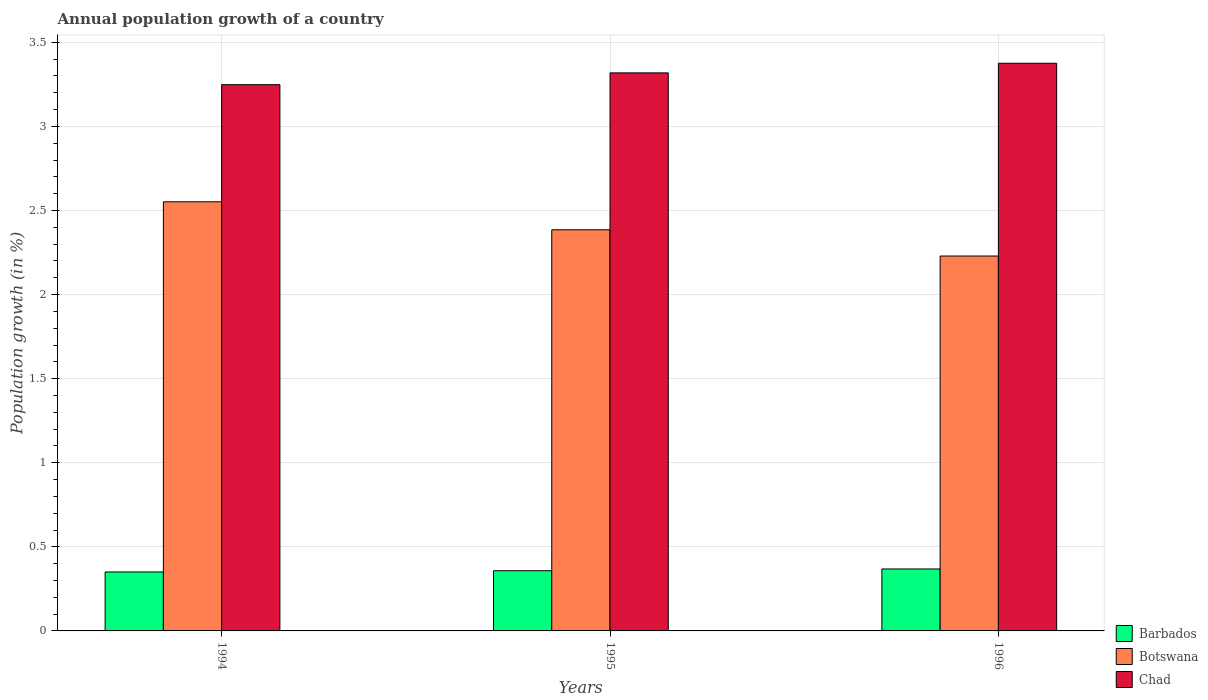Are the number of bars per tick equal to the number of legend labels?
Give a very brief answer. Yes. Are the number of bars on each tick of the X-axis equal?
Make the answer very short. Yes. How many bars are there on the 3rd tick from the right?
Make the answer very short. 3. What is the label of the 1st group of bars from the left?
Ensure brevity in your answer.  1994. What is the annual population growth in Barbados in 1995?
Give a very brief answer. 0.36. Across all years, what is the maximum annual population growth in Botswana?
Your response must be concise. 2.55. Across all years, what is the minimum annual population growth in Chad?
Offer a terse response. 3.25. In which year was the annual population growth in Barbados minimum?
Your answer should be compact. 1994. What is the total annual population growth in Barbados in the graph?
Ensure brevity in your answer.  1.08. What is the difference between the annual population growth in Chad in 1994 and that in 1995?
Your answer should be very brief. -0.07. What is the difference between the annual population growth in Barbados in 1996 and the annual population growth in Chad in 1994?
Ensure brevity in your answer.  -2.88. What is the average annual population growth in Barbados per year?
Offer a terse response. 0.36. In the year 1994, what is the difference between the annual population growth in Barbados and annual population growth in Botswana?
Make the answer very short. -2.2. What is the ratio of the annual population growth in Barbados in 1994 to that in 1996?
Ensure brevity in your answer.  0.95. What is the difference between the highest and the second highest annual population growth in Botswana?
Offer a very short reply. 0.17. What is the difference between the highest and the lowest annual population growth in Barbados?
Your answer should be compact. 0.02. What does the 3rd bar from the left in 1996 represents?
Provide a short and direct response. Chad. What does the 2nd bar from the right in 1994 represents?
Offer a very short reply. Botswana. How many years are there in the graph?
Your response must be concise. 3. What is the difference between two consecutive major ticks on the Y-axis?
Ensure brevity in your answer.  0.5. Does the graph contain any zero values?
Your response must be concise. No. Does the graph contain grids?
Make the answer very short. Yes. Where does the legend appear in the graph?
Make the answer very short. Bottom right. How are the legend labels stacked?
Offer a very short reply. Vertical. What is the title of the graph?
Your response must be concise. Annual population growth of a country. Does "Central African Republic" appear as one of the legend labels in the graph?
Give a very brief answer. No. What is the label or title of the Y-axis?
Make the answer very short. Population growth (in %). What is the Population growth (in %) of Barbados in 1994?
Offer a terse response. 0.35. What is the Population growth (in %) of Botswana in 1994?
Your response must be concise. 2.55. What is the Population growth (in %) of Chad in 1994?
Your answer should be very brief. 3.25. What is the Population growth (in %) in Barbados in 1995?
Make the answer very short. 0.36. What is the Population growth (in %) of Botswana in 1995?
Give a very brief answer. 2.39. What is the Population growth (in %) in Chad in 1995?
Your answer should be very brief. 3.32. What is the Population growth (in %) in Barbados in 1996?
Ensure brevity in your answer.  0.37. What is the Population growth (in %) in Botswana in 1996?
Provide a short and direct response. 2.23. What is the Population growth (in %) in Chad in 1996?
Ensure brevity in your answer.  3.38. Across all years, what is the maximum Population growth (in %) in Barbados?
Offer a terse response. 0.37. Across all years, what is the maximum Population growth (in %) of Botswana?
Provide a succinct answer. 2.55. Across all years, what is the maximum Population growth (in %) of Chad?
Make the answer very short. 3.38. Across all years, what is the minimum Population growth (in %) in Barbados?
Keep it short and to the point. 0.35. Across all years, what is the minimum Population growth (in %) of Botswana?
Make the answer very short. 2.23. Across all years, what is the minimum Population growth (in %) of Chad?
Keep it short and to the point. 3.25. What is the total Population growth (in %) in Barbados in the graph?
Your answer should be compact. 1.08. What is the total Population growth (in %) in Botswana in the graph?
Ensure brevity in your answer.  7.17. What is the total Population growth (in %) in Chad in the graph?
Offer a very short reply. 9.94. What is the difference between the Population growth (in %) of Barbados in 1994 and that in 1995?
Offer a very short reply. -0.01. What is the difference between the Population growth (in %) in Botswana in 1994 and that in 1995?
Your response must be concise. 0.17. What is the difference between the Population growth (in %) in Chad in 1994 and that in 1995?
Keep it short and to the point. -0.07. What is the difference between the Population growth (in %) of Barbados in 1994 and that in 1996?
Keep it short and to the point. -0.02. What is the difference between the Population growth (in %) of Botswana in 1994 and that in 1996?
Offer a very short reply. 0.32. What is the difference between the Population growth (in %) in Chad in 1994 and that in 1996?
Ensure brevity in your answer.  -0.13. What is the difference between the Population growth (in %) of Barbados in 1995 and that in 1996?
Give a very brief answer. -0.01. What is the difference between the Population growth (in %) in Botswana in 1995 and that in 1996?
Give a very brief answer. 0.16. What is the difference between the Population growth (in %) of Chad in 1995 and that in 1996?
Your response must be concise. -0.06. What is the difference between the Population growth (in %) in Barbados in 1994 and the Population growth (in %) in Botswana in 1995?
Provide a short and direct response. -2.03. What is the difference between the Population growth (in %) in Barbados in 1994 and the Population growth (in %) in Chad in 1995?
Provide a succinct answer. -2.97. What is the difference between the Population growth (in %) of Botswana in 1994 and the Population growth (in %) of Chad in 1995?
Make the answer very short. -0.77. What is the difference between the Population growth (in %) of Barbados in 1994 and the Population growth (in %) of Botswana in 1996?
Your response must be concise. -1.88. What is the difference between the Population growth (in %) in Barbados in 1994 and the Population growth (in %) in Chad in 1996?
Provide a succinct answer. -3.02. What is the difference between the Population growth (in %) in Botswana in 1994 and the Population growth (in %) in Chad in 1996?
Your answer should be compact. -0.82. What is the difference between the Population growth (in %) of Barbados in 1995 and the Population growth (in %) of Botswana in 1996?
Provide a succinct answer. -1.87. What is the difference between the Population growth (in %) of Barbados in 1995 and the Population growth (in %) of Chad in 1996?
Provide a short and direct response. -3.02. What is the difference between the Population growth (in %) in Botswana in 1995 and the Population growth (in %) in Chad in 1996?
Provide a succinct answer. -0.99. What is the average Population growth (in %) in Barbados per year?
Keep it short and to the point. 0.36. What is the average Population growth (in %) of Botswana per year?
Ensure brevity in your answer.  2.39. What is the average Population growth (in %) of Chad per year?
Your answer should be very brief. 3.31. In the year 1994, what is the difference between the Population growth (in %) of Barbados and Population growth (in %) of Botswana?
Offer a terse response. -2.2. In the year 1994, what is the difference between the Population growth (in %) in Barbados and Population growth (in %) in Chad?
Provide a short and direct response. -2.9. In the year 1994, what is the difference between the Population growth (in %) of Botswana and Population growth (in %) of Chad?
Your answer should be very brief. -0.7. In the year 1995, what is the difference between the Population growth (in %) in Barbados and Population growth (in %) in Botswana?
Offer a terse response. -2.03. In the year 1995, what is the difference between the Population growth (in %) in Barbados and Population growth (in %) in Chad?
Offer a very short reply. -2.96. In the year 1995, what is the difference between the Population growth (in %) of Botswana and Population growth (in %) of Chad?
Your answer should be very brief. -0.93. In the year 1996, what is the difference between the Population growth (in %) in Barbados and Population growth (in %) in Botswana?
Offer a very short reply. -1.86. In the year 1996, what is the difference between the Population growth (in %) in Barbados and Population growth (in %) in Chad?
Your answer should be very brief. -3.01. In the year 1996, what is the difference between the Population growth (in %) of Botswana and Population growth (in %) of Chad?
Your response must be concise. -1.15. What is the ratio of the Population growth (in %) of Barbados in 1994 to that in 1995?
Your response must be concise. 0.98. What is the ratio of the Population growth (in %) in Botswana in 1994 to that in 1995?
Give a very brief answer. 1.07. What is the ratio of the Population growth (in %) of Chad in 1994 to that in 1995?
Your response must be concise. 0.98. What is the ratio of the Population growth (in %) of Barbados in 1994 to that in 1996?
Provide a short and direct response. 0.95. What is the ratio of the Population growth (in %) of Botswana in 1994 to that in 1996?
Provide a short and direct response. 1.14. What is the ratio of the Population growth (in %) in Chad in 1994 to that in 1996?
Ensure brevity in your answer.  0.96. What is the ratio of the Population growth (in %) in Barbados in 1995 to that in 1996?
Your response must be concise. 0.97. What is the ratio of the Population growth (in %) of Botswana in 1995 to that in 1996?
Ensure brevity in your answer.  1.07. What is the ratio of the Population growth (in %) of Chad in 1995 to that in 1996?
Your answer should be very brief. 0.98. What is the difference between the highest and the second highest Population growth (in %) of Barbados?
Provide a short and direct response. 0.01. What is the difference between the highest and the second highest Population growth (in %) in Botswana?
Your answer should be very brief. 0.17. What is the difference between the highest and the second highest Population growth (in %) in Chad?
Make the answer very short. 0.06. What is the difference between the highest and the lowest Population growth (in %) of Barbados?
Your answer should be very brief. 0.02. What is the difference between the highest and the lowest Population growth (in %) of Botswana?
Your answer should be compact. 0.32. What is the difference between the highest and the lowest Population growth (in %) of Chad?
Provide a succinct answer. 0.13. 